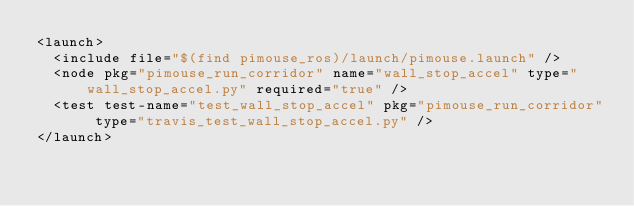<code> <loc_0><loc_0><loc_500><loc_500><_XML_><launch>
  <include file="$(find pimouse_ros)/launch/pimouse.launch" />
  <node pkg="pimouse_run_corridor" name="wall_stop_accel" type="wall_stop_accel.py" required="true" />
  <test test-name="test_wall_stop_accel" pkg="pimouse_run_corridor" type="travis_test_wall_stop_accel.py" />
</launch></code> 